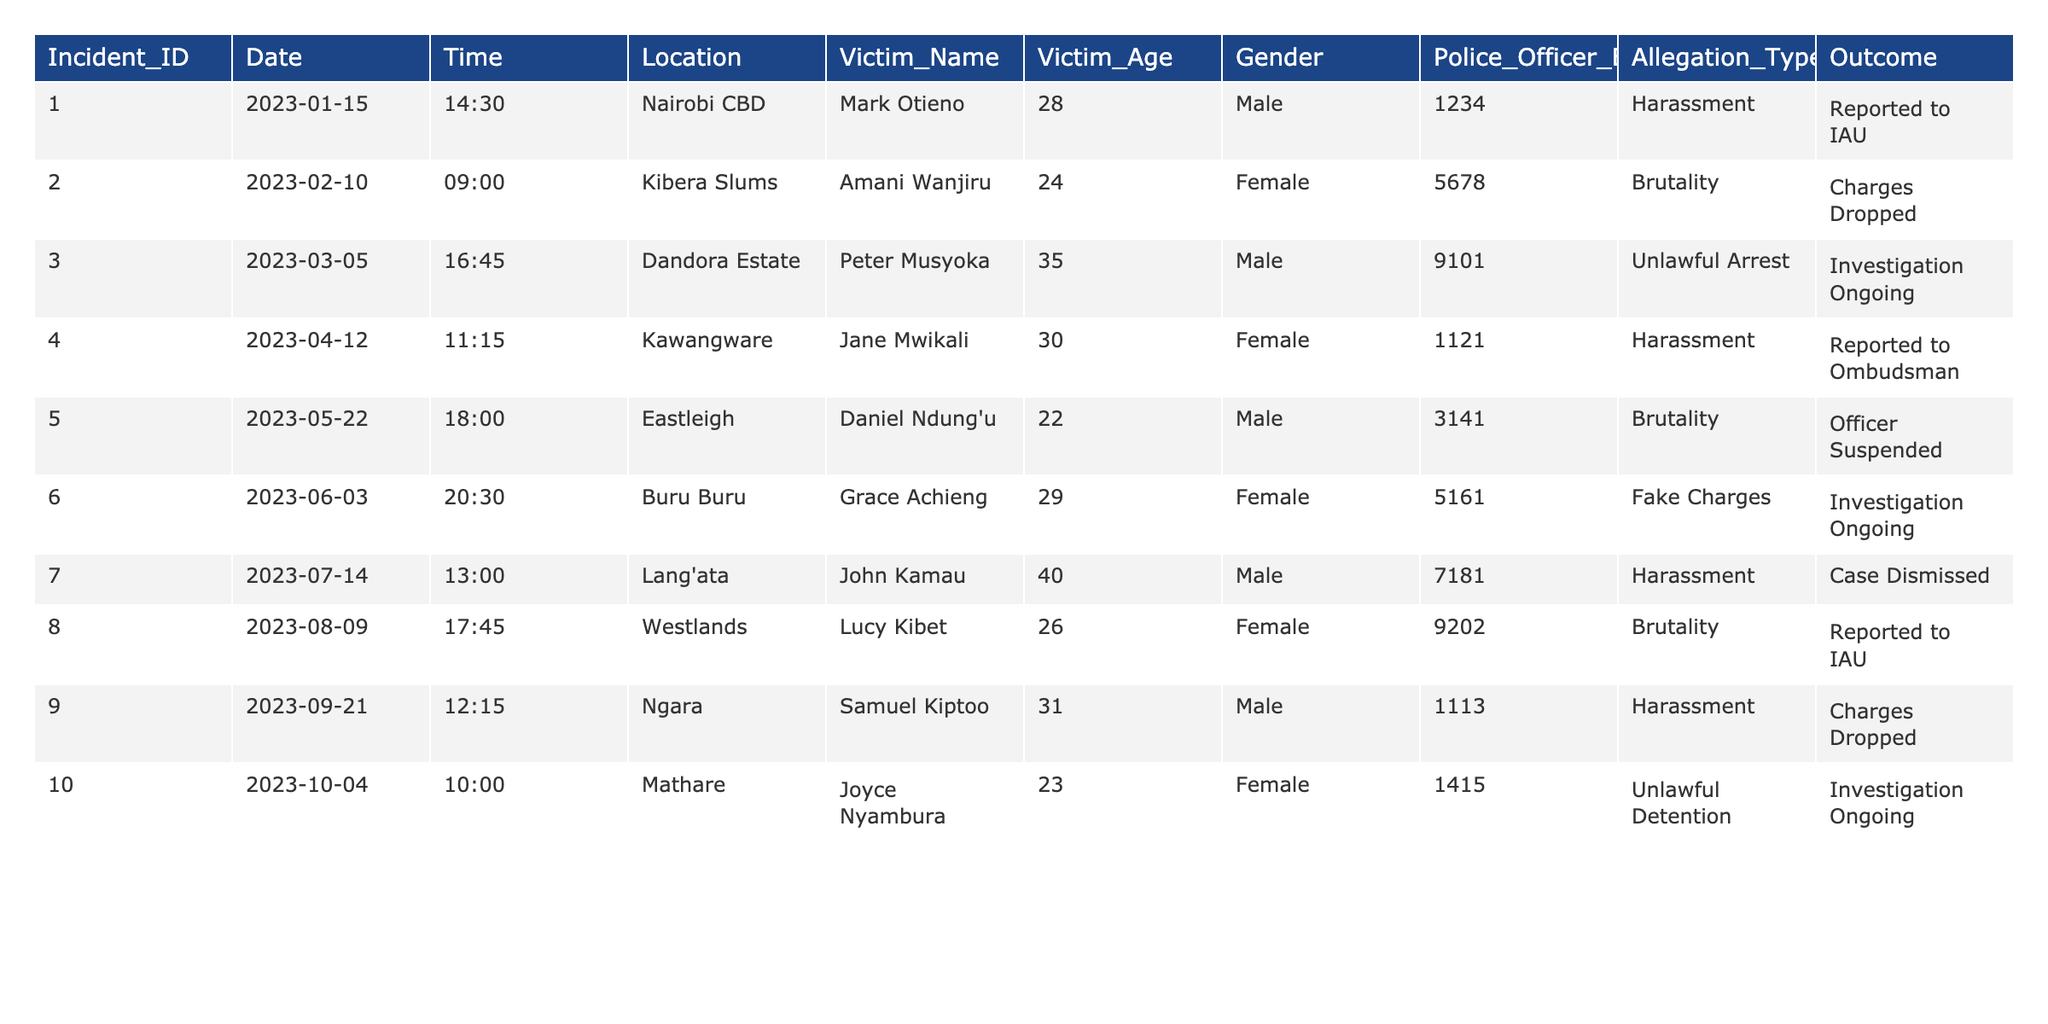What is the most common type of allegation reported in the table? By examining the "Allegation_Type" column, we see the types of allegations made against police officers. The types listed are Harassment, Brutality, Unlawful Arrest, Fake Charges, and Unlawful Detention. Counting the occurrences, "Harassment" appears 4 times, "Brutality" 3 times, and others less frequently. Therefore, Harassment is the most common allegation type.
Answer: Harassment How many incidents were reported as "Investigation Ongoing"? Looking at the Outcome column, we count the instances that say "Investigation Ongoing". There are 4 incidents where this is mentioned.
Answer: 4 What was the age of the youngest victim in the reported incidents? The ages of the victims can be found in the "Victim_Age" column. By reviewing these ages, the youngest victim is 22 years old.
Answer: 22 How many allegations resulted in charges being dropped? We look for "Charges Dropped" in the Outcome column to find the number of incidents that fit this description. There are 3 instances where this occurred.
Answer: 3 Is there any incident where a police officer was suspended? Checking the Outcome column for mentions of suspensions, we find that Officer from the incident involving Daniel Ndung'u was suspended. Therefore, yes, there is at least one such incident.
Answer: Yes What types of allegations were made by female victims? By filtering the table for female victims and checking the "Allegation_Type" column, the allegations are Harassment, Brutality, and Fake Charges. Thus, female victims made three types of allegations.
Answer: 3 types (Harassment, Brutality, Fake Charges) Which location had the highest number of reported incidents? We analyze the "Location" column to count the occurrences of each location. Nairobi CBD is mentioned once, Kibera Slums once, Dandora Estate once, etc., with no location repeated. Therefore, all locations have one incident each.
Answer: No location has a higher count; all are equal What was the outcome of the incident involving Joyce Nyambura? Referring to the "Outcome" column for the row corresponding to Joyce Nyambura shows that the outcome is "Investigation Ongoing".
Answer: Investigation Ongoing What percentage of incidents led to a reported outcome in the table? The total number of incidents is 10. The only outcomes that are undefined are those that led to "Investigation Ongoing" as the final states, counted 4 out of 10. The percentage is thus (6/10) * 100 = 60%.
Answer: 60% How many males reported incidents of police harassment? We look specifically for male victims in the "Allegation_Type" column marked as "Harassment". There are 3 male victims who reported harassment.
Answer: 3 males Which month had the highest number of reported incidents? By examining the Date column, we tally the number of incidents for each month. Every month from January to October has 1 or more reported incidents, with March being the peak month having 4 incidents reported.
Answer: March 